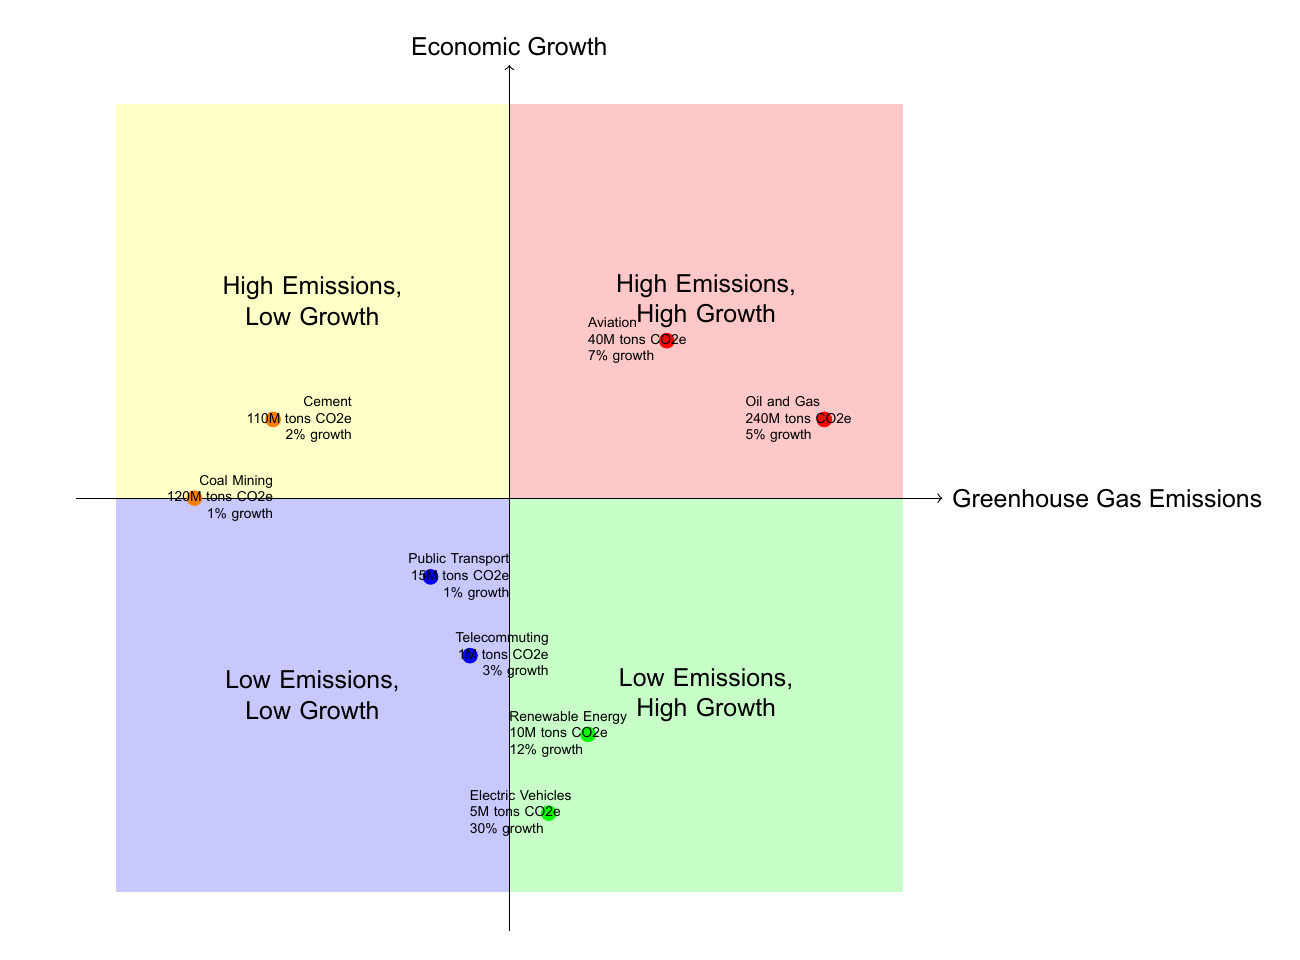What sector has the highest GHG emissions? The sector with the highest GHG emissions, as indicated in the diagram, is Oil and Gas with 240 million tons CO2e.
Answer: Oil and Gas What is the economic growth rate for Renewable Energy? According to the diagram, the economic growth rate for Renewable Energy is 12% annual revenue growth.
Answer: 12% annual revenue growth How many sectors fall into the "Low Emissions, Low Growth" quadrant? The diagram displays two sectors in the "Low Emissions, Low Growth" quadrant, which are Public Transportation and Telecommuting Solutions.
Answer: 2 Which sector has the least GHG emissions? Telecommuting Solutions has the least GHG emissions at 1 million tons CO2e.
Answer: Telecommuting Solutions Compare the GHG emissions of Electric Vehicles and Aviation. Electric Vehicles have 5 million tons CO2e, while Aviation has 40 million tons CO2e. This indicates that Electric Vehicles have significantly lower emissions than Aviation.
Answer: Electric Vehicles are lower What is the economic growth for the Coal Mining sector? The economic growth for the Coal Mining sector is 1% annual revenue growth, as shown in the diagram.
Answer: 1% annual revenue growth Which quadrant contains sectors with high emissions but low growth? The "High Emissions, Low Growth" quadrant contains sectors like Coal Mining and Cement Production, both characterized by significant emissions and minimal economic growth.
Answer: High Emissions, Low Growth What is the difference in economic growth between Electric Vehicles and Coal Mining? Electric Vehicles show a significantly higher economic growth rate of 30% compared to Coal Mining’s 1%. The difference is 29%.
Answer: 29% How many total sectors are represented in the diagram? The diagram features a total of eight sectors, distributed across the four quadrants.
Answer: 8 